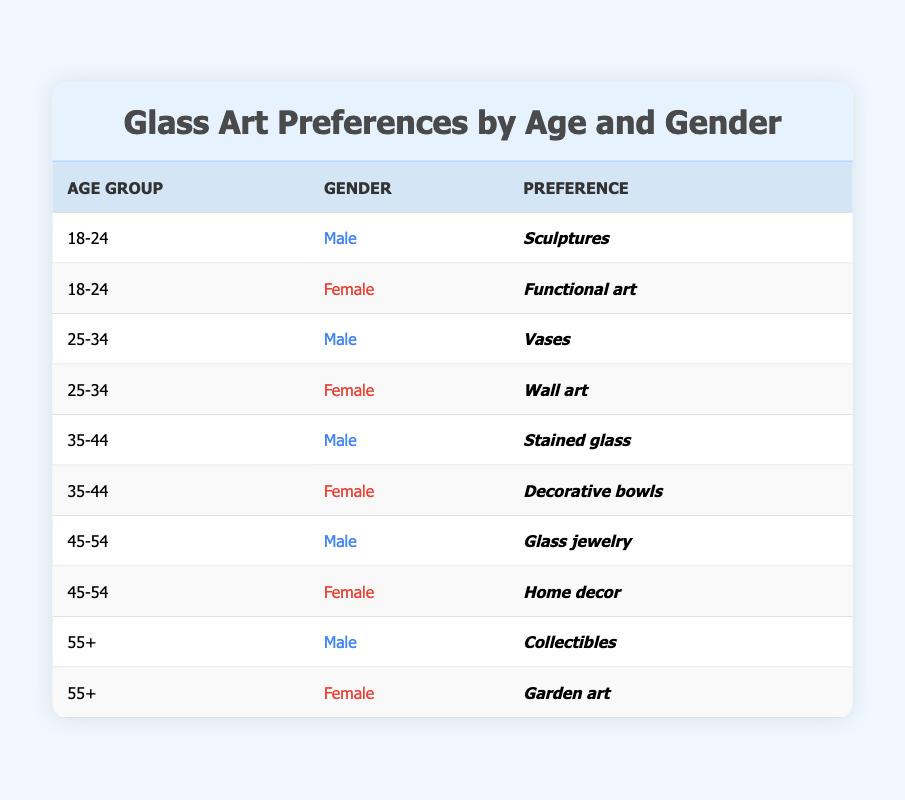What is the glass art preference for females aged 18-24? According to the table, the only preference listed for females in the age group 18-24 is "Functional art." We can find this by looking at the row that specifies the age group as 18-24 and the gender as Female.
Answer: Functional art Which age group shows a preference for "Stained glass"? The table lists "Stained glass" under the Male gender for the age group 35-44. To answer this, we look for the preference "Stained glass" and find its corresponding age group.
Answer: 35-44 Are there more male or female preferences listed for ages 45-54? In the age group 45-54, the preferences are "Glass jewelry" for males and "Home decor" for females. Since there is one preference for each gender, we conclude that the number of preferences is equal.
Answer: Equal What is the most common glass art preference among males aged 55 and older? From the table, males aged 55+ prefer "Collectibles." This is determined by locating the row for age group 55+ and identifying the corresponding preference for males.
Answer: Collectibles Count the total number of unique glass art preferences for all age groups and genders combined. The preferences listed in the table are: Sculptures, Functional art, Vases, Wall art, Stained glass, Decorative bowls, Glass jewelry, Home decor, Collectibles, and Garden art. This adds up to 10 unique preferences.
Answer: 10 Which age group has a preference for "Vases"? The table shows that the preference for "Vases" is associated with males aged 25-34. We find this by checking the row for the preference "Vases" and noting the connected age group.
Answer: 25-34 Do any females prefer "Garden art"? Yes, according to the table, the preference for "Garden art" is listed for females aged 55 and older. This data point can be found by searching for the preference "Garden art" and checking the corresponding gender and age group.
Answer: Yes Which preference is associated with the oldest age group in the table? The oldest age group is 55+, and the preferences listed are "Collectibles" for males and "Garden art" for females. So, we check the rows for the age group 55+ to gather both preferences.
Answer: Collectibles and Garden art 